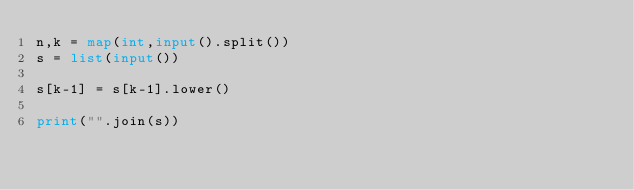<code> <loc_0><loc_0><loc_500><loc_500><_Python_>n,k = map(int,input().split())
s = list(input())

s[k-1] = s[k-1].lower()

print("".join(s))</code> 